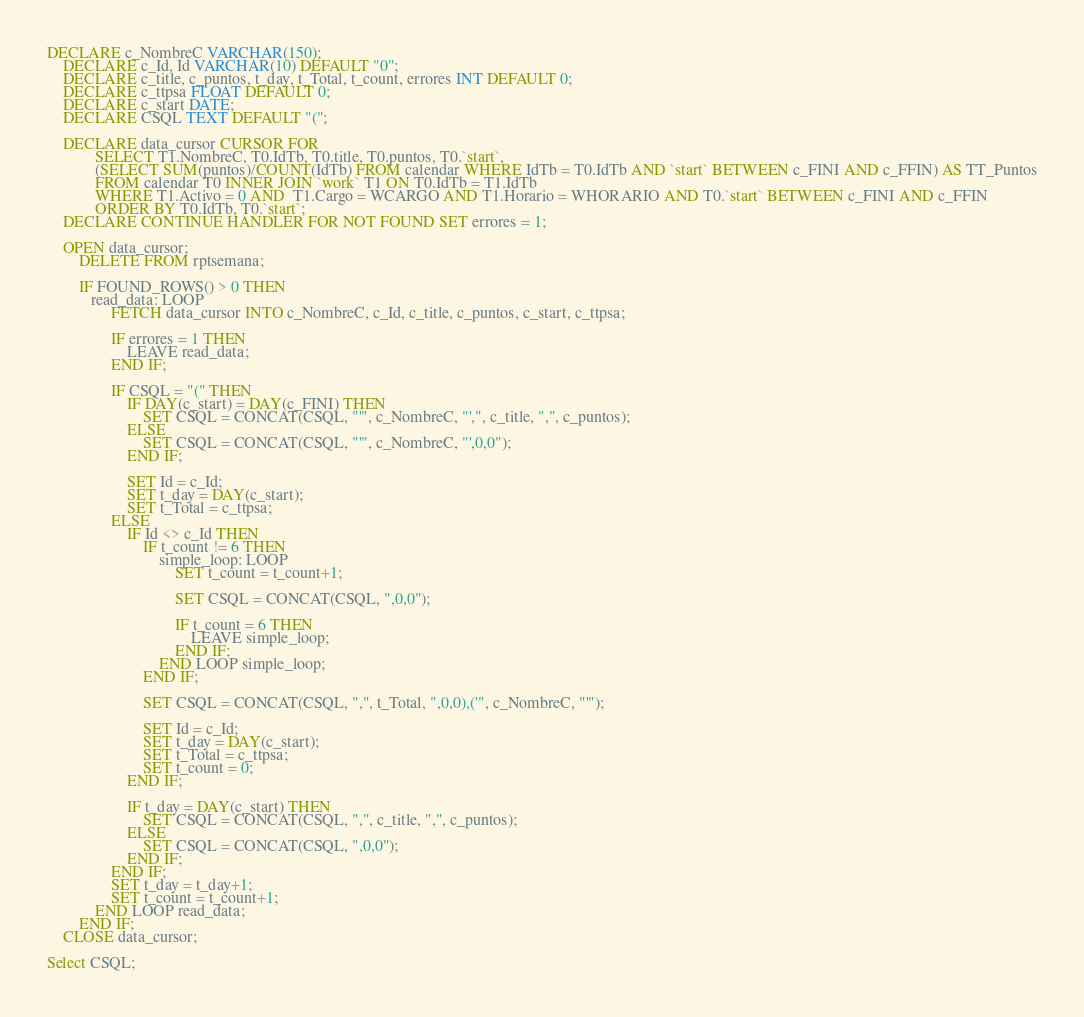<code> <loc_0><loc_0><loc_500><loc_500><_SQL_>

DECLARE c_NombreC VARCHAR(150); 
	DECLARE c_Id, Id VARCHAR(10) DEFAULT "0"; 
	DECLARE c_title, c_puntos, t_day, t_Total, t_count, errores INT DEFAULT 0;
	DECLARE c_ttpsa FLOAT DEFAULT 0;
	DECLARE c_start DATE;
	DECLARE CSQL TEXT DEFAULT "(";

	DECLARE data_cursor CURSOR FOR 
			SELECT T1.NombreC, T0.IdTb, T0.title, T0.puntos, T0.`start`,
			(SELECT SUM(puntos)/COUNT(IdTb) FROM calendar WHERE IdTb = T0.IdTb AND `start` BETWEEN c_FINI AND c_FFIN) AS TT_Puntos
			FROM calendar T0 INNER JOIN `work` T1 ON T0.IdTb = T1.IdTb
			WHERE T1.Activo = 0 AND  T1.Cargo = WCARGO AND T1.Horario = WHORARIO AND T0.`start` BETWEEN c_FINI AND c_FFIN
			ORDER BY T0.IdTb, T0.`start`;
	DECLARE CONTINUE HANDLER FOR NOT FOUND SET errores = 1;
	
	OPEN data_cursor;
		DELETE FROM rptsemana;

		IF FOUND_ROWS() > 0 THEN
		   read_data: LOOP
				FETCH data_cursor INTO c_NombreC, c_Id, c_title, c_puntos, c_start, c_ttpsa;
				
				IF errores = 1 THEN
					LEAVE read_data;
				END IF;
				
				IF CSQL = "(" THEN
					IF DAY(c_start) = DAY(c_FINI) THEN
						SET CSQL = CONCAT(CSQL, "'", c_NombreC, "',", c_title, ",", c_puntos);
					ELSE
						SET CSQL = CONCAT(CSQL, "'", c_NombreC, "',0,0");
					END IF;
					
					SET Id = c_Id;
					SET t_day = DAY(c_start);
					SET t_Total = c_ttpsa;
				ELSE
					IF Id <> c_Id THEN
						IF t_count != 6 THEN
							simple_loop: LOOP
								SET t_count = t_count+1;

								SET CSQL = CONCAT(CSQL, ",0,0");
								
								IF t_count = 6 THEN
									LEAVE simple_loop;
								END IF;
							END LOOP simple_loop;
						END IF;

						SET CSQL = CONCAT(CSQL, ",", t_Total, ",0,0),('", c_NombreC, "'");

						SET Id = c_Id;
						SET t_day = DAY(c_start);
						SET t_Total = c_ttpsa;
						SET t_count = 0;
					END IF;
					
					IF t_day = DAY(c_start) THEN
						SET CSQL = CONCAT(CSQL, ",", c_title, ",", c_puntos);
					ELSE
						SET CSQL = CONCAT(CSQL, ",0,0");
					END IF;
				END IF;
				SET t_day = t_day+1;
				SET t_count = t_count+1;
			END LOOP read_data;
		END IF;
	CLOSE data_cursor;

Select CSQL;</code> 